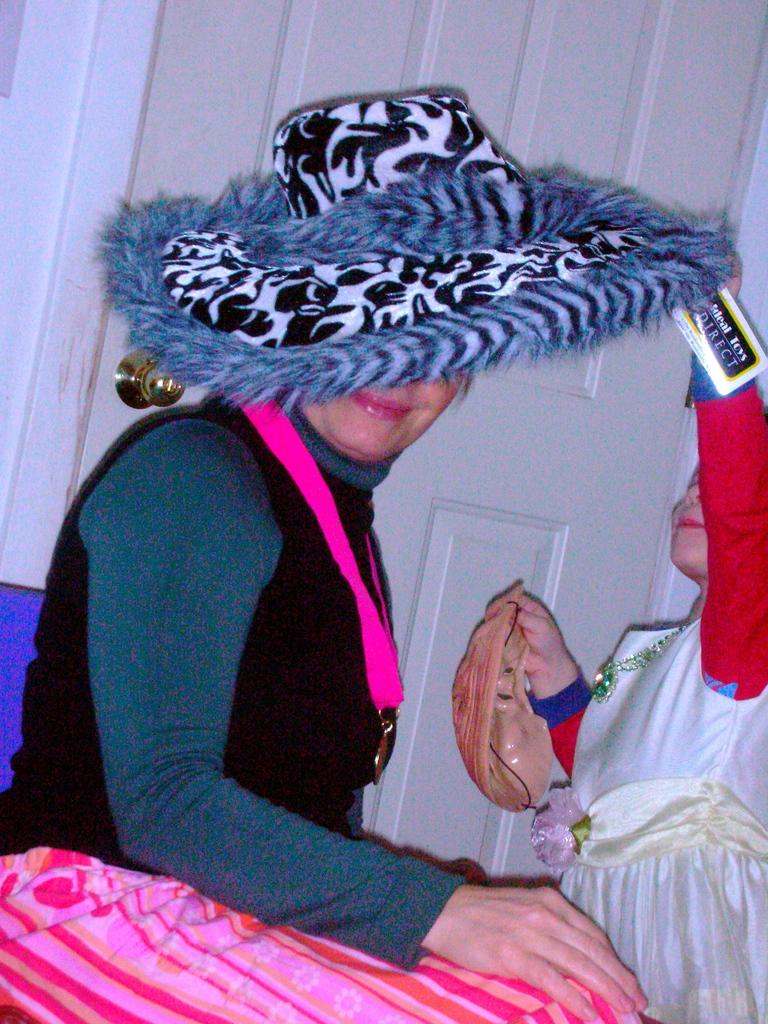Who is the main subject in the center of the image? There is a lady in the center of the image. What is the lady wearing on her head? The lady is wearing a hat. What can be seen on the left side of the image? There is a kid on the left side of the image. What is the kid holding in their hand? The kid is holding a mask. What architectural feature is visible in the background of the image? There is a door visible in the background of the image. What type of tub can be seen in the image? There is no tub present in the image. Can you tell me how many twigs are being used as a whistle by the lady? There are no twigs or whistles present in the image. 